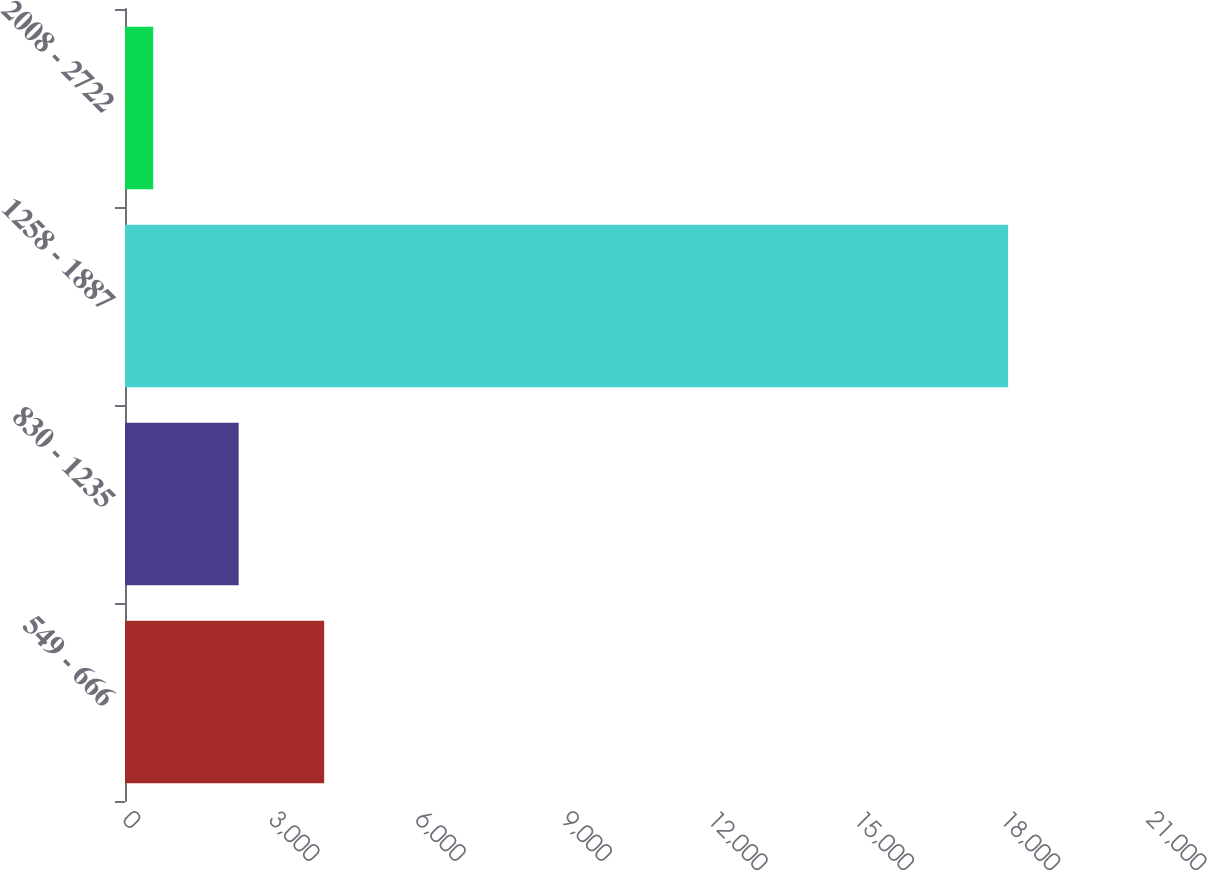Convert chart to OTSL. <chart><loc_0><loc_0><loc_500><loc_500><bar_chart><fcel>549 - 666<fcel>830 - 1235<fcel>1258 - 1887<fcel>2008 - 2722<nl><fcel>4084.6<fcel>2331.3<fcel>18111<fcel>578<nl></chart> 